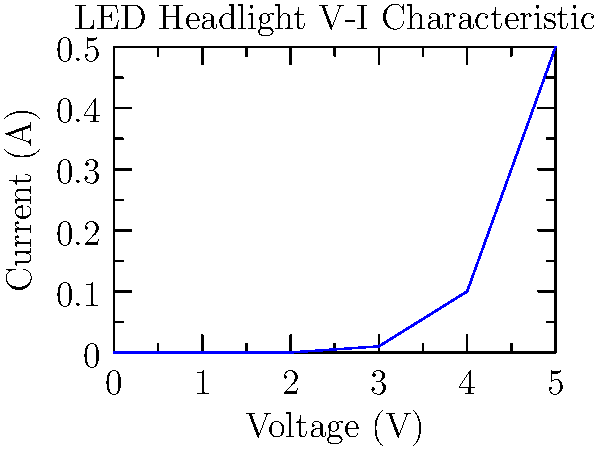Analyzing the voltage-current characteristic graph of LED headlights, at what approximate voltage does the LED start conducting a significant amount of current? To determine when the LED starts conducting a significant amount of current, we need to analyze the graph:

1. Observe the shape of the curve: It's relatively flat near the origin and then rises sharply.
2. Look for the "knee" of the curve: This is where the current starts to increase notably.
3. Estimate the voltage at this point: The curve begins to rise steeply at around 3V.
4. Confirm by checking current values:
   - At 2V and below, current is negligible (approximately 0A).
   - At 3V, there's a small but noticeable current (about 0.01A).
   - After 3V, current increases rapidly.

Therefore, the LED starts conducting a significant amount of current at approximately 3V. This voltage is often referred to as the "forward voltage" or "turn-on voltage" of the LED.
Answer: Approximately 3V 